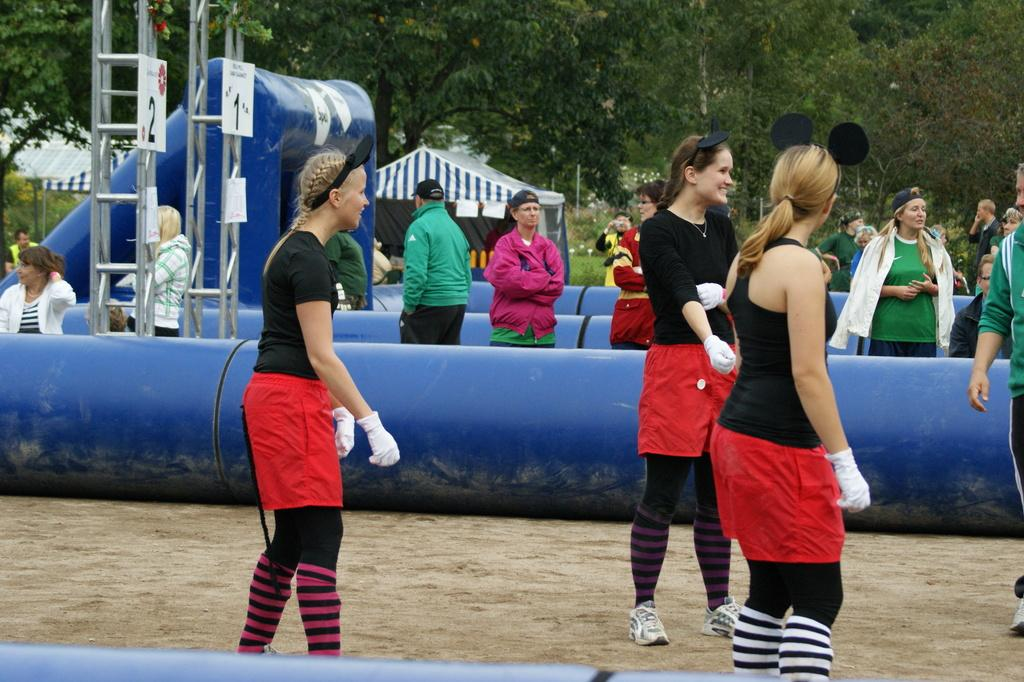What are the people in the image doing? The people in the image are standing on the ground. What else can be seen in the image besides the people? There are balloons in the image. What can be seen in the background of the image? There are trees in the background of the image. What type of pot is being used to cook the turkey in the image? There is no pot or turkey present in the image. 